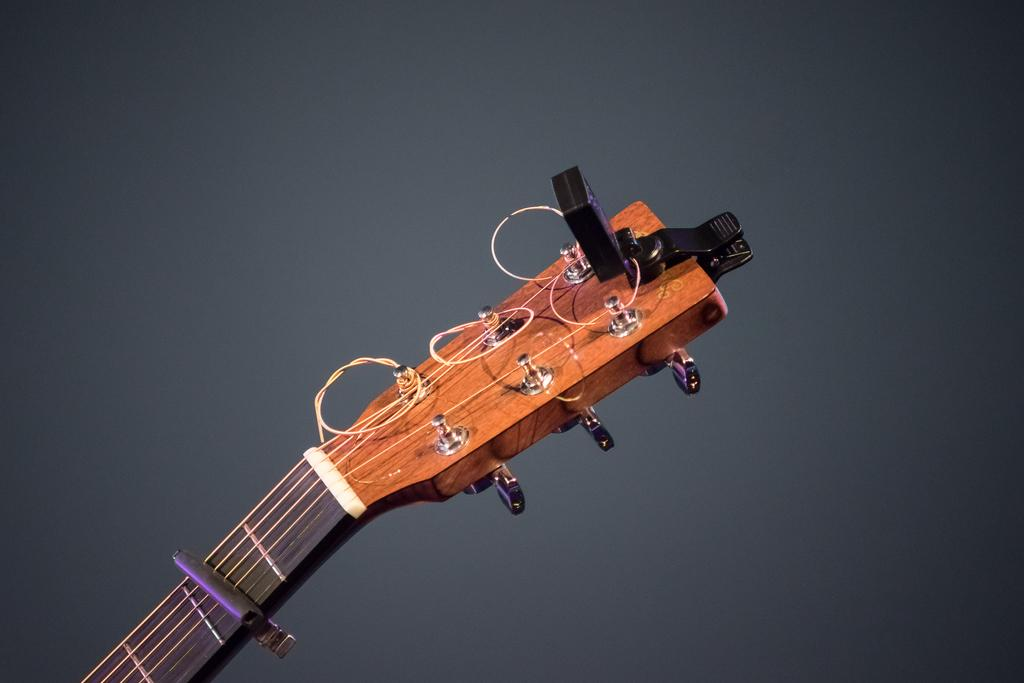What type of musical instrument is partially visible in the image? There is an upper part of a guitar in the image. What is attached to the strings in the image? The strings are attached to a clip in the image. What type of poison is being used to increase the skin's elasticity in the image? There is no mention of poison, increase, or skin in the image; it only features an upper part of a guitar and strings attached to a clip. 